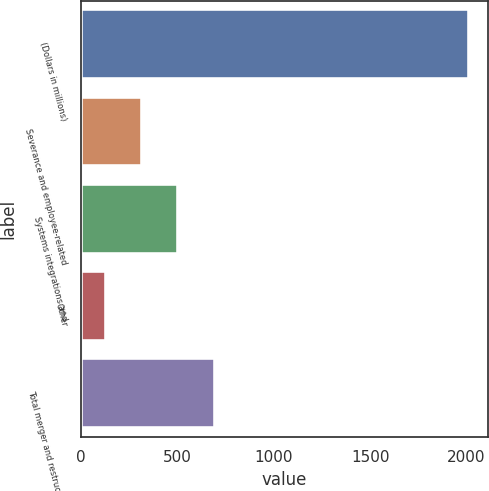Convert chart to OTSL. <chart><loc_0><loc_0><loc_500><loc_500><bar_chart><fcel>(Dollars in millions)<fcel>Severance and employee-related<fcel>Systems integrations and<fcel>Other<fcel>Total merger and restructuring<nl><fcel>2011<fcel>315.4<fcel>503.8<fcel>127<fcel>692.2<nl></chart> 